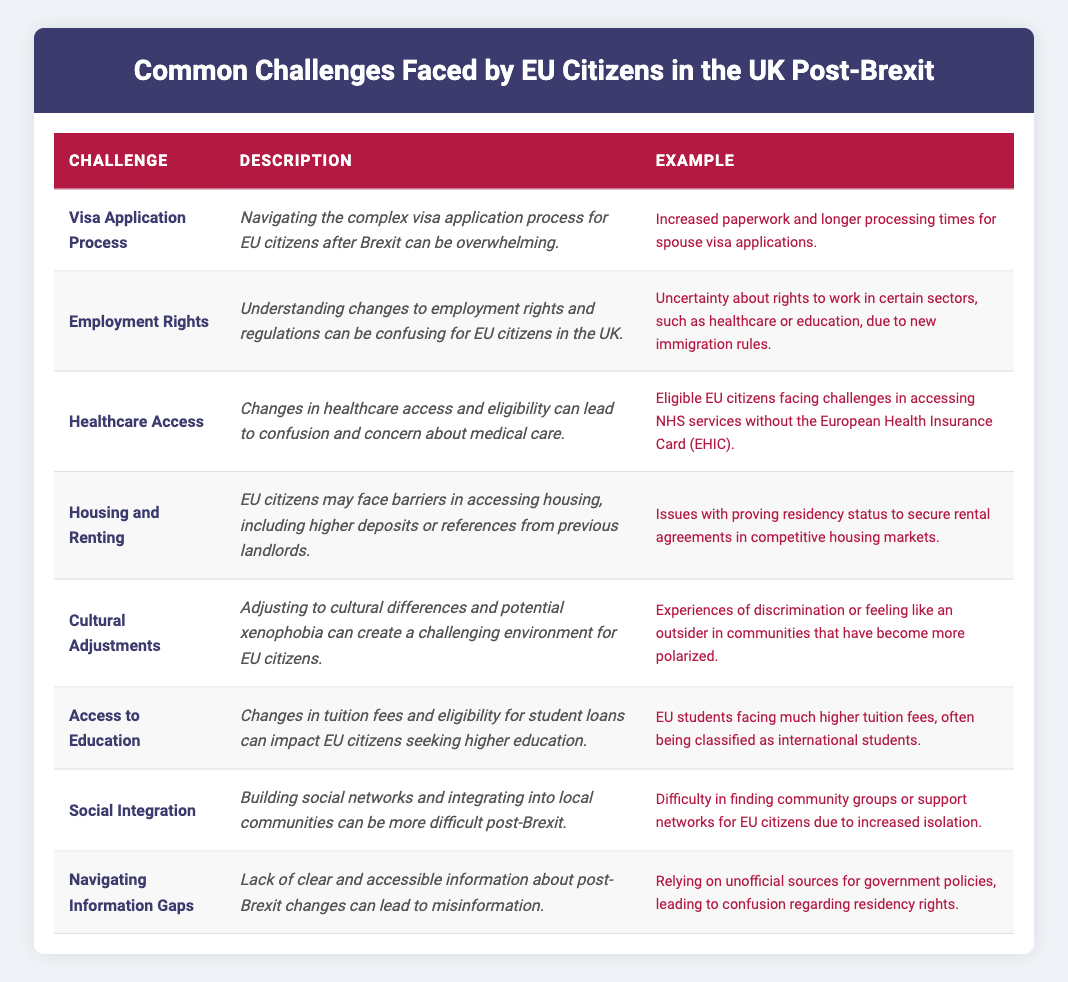What is one example of a challenge related to the visa application process? The table explicitly states that one example of a challenge related to the visa application process is "Increased paperwork and longer processing times for spouse visa applications."
Answer: Increased paperwork and longer processing times for spouse visa applications How many challenges are listed in the table? The table outlines a total of eight challenges faced by EU citizens in the UK post-Brexit.
Answer: Eight challenges Is there a challenge related to cultural adjustments? Yes, the table includes "Cultural Adjustments" as one of the challenges faced by EU citizens.
Answer: Yes What are the two challenges that mention difficulties in accessing services? The challenges that mention difficulties in accessing services are "Healthcare Access" and "Housing and Renting."
Answer: Healthcare Access and Housing and Renting Which challenge pertains to changes in education for EU citizens? The "Access to Education" challenge specifically addresses changes in tuition fees and eligibility for EU citizens seeking higher education.
Answer: Access to Education If we summarize the challenges in terms of confusion about rights or access, how many of them fall into that category? The challenges that fall into the category of confusion about rights or access are "Employment Rights," "Healthcare Access," and "Navigating Information Gaps," making a total of three.
Answer: Three challenges Is there a specific example mentioned for challenges regarding housing and renting? Yes, the table provides an example stating that issues with proving residency status to secure rental agreements in competitive housing markets represent a challenge for EU citizens.
Answer: Yes What might be a reason for increased barriers in housing and renting for EU citizens? The table indicates that EU citizens face higher deposits and references from previous landlords, which could contribute to these barriers.
Answer: Higher deposits and references Based on the table, which challenge highlights feelings of isolation and difficulty in community integration? "Social Integration" highlights issues with building social networks and increased isolation for EU citizens post-Brexit.
Answer: Social Integration Can you identify a challenge that involves misinformation about residency rights? The challenge titled "Navigating Information Gaps" discusses the issue of misinformation regarding residency rights due to a lack of clear and accessible information.
Answer: Navigating Information Gaps 